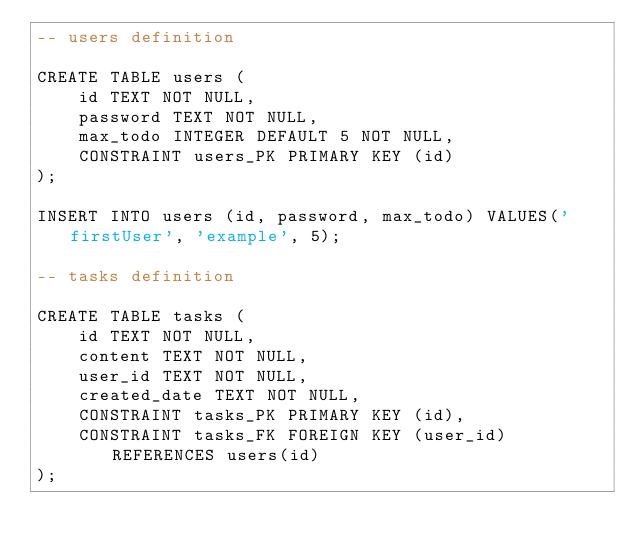Convert code to text. <code><loc_0><loc_0><loc_500><loc_500><_SQL_>-- users definition

CREATE TABLE users (
	id TEXT NOT NULL,
	password TEXT NOT NULL,
	max_todo INTEGER DEFAULT 5 NOT NULL,
	CONSTRAINT users_PK PRIMARY KEY (id)
);

INSERT INTO users (id, password, max_todo) VALUES('firstUser', 'example', 5);

-- tasks definition

CREATE TABLE tasks (
	id TEXT NOT NULL,
	content TEXT NOT NULL,
	user_id TEXT NOT NULL,
    created_date TEXT NOT NULL,
	CONSTRAINT tasks_PK PRIMARY KEY (id),
	CONSTRAINT tasks_FK FOREIGN KEY (user_id) REFERENCES users(id)
);</code> 